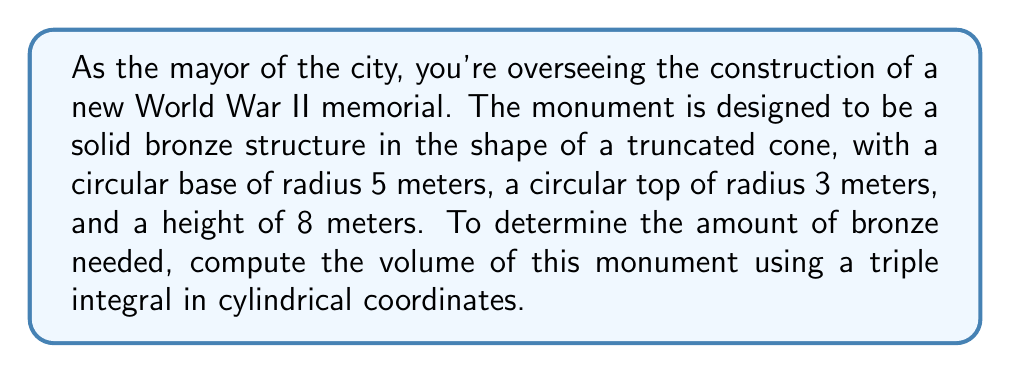Solve this math problem. To solve this problem, we'll use cylindrical coordinates $(r, \theta, z)$ and set up a triple integral to calculate the volume of the truncated cone.

1) First, let's identify the limits of integration:
   - $0 \leq \theta \leq 2\pi$ (full rotation around the z-axis)
   - $0 \leq z \leq 8$ (height of the monument)
   - For $r$, we need to find a function that describes how the radius changes with height.

2) The radius at any height $z$ can be described by the equation:
   $r(z) = 5 - \frac{1}{4}z$
   This is because the radius decreases from 5m to 3m over a height of 8m.

3) The volume element in cylindrical coordinates is $dV = r \, dr \, d\theta \, dz$.

4) We can now set up the triple integral:

   $$V = \int_0^{2\pi} \int_0^8 \int_0^{5-\frac{1}{4}z} r \, dr \, dz \, d\theta$$

5) Let's solve the innermost integral first:
   $$\int_0^{5-\frac{1}{4}z} r \, dr = \frac{1}{2}r^2 \bigg|_0^{5-\frac{1}{4}z} = \frac{1}{2}(5-\frac{1}{4}z)^2$$

6) Now our integral becomes:
   $$V = \int_0^{2\pi} \int_0^8 \frac{1}{2}(5-\frac{1}{4}z)^2 \, dz \, d\theta$$

7) Let's solve the $z$ integral:
   $$\int_0^8 \frac{1}{2}(5-\frac{1}{4}z)^2 \, dz = \frac{1}{2} \int_0^8 (25 - \frac{5}{2}z + \frac{1}{32}z^2) \, dz$$
   $$= \frac{1}{2} [25z - \frac{5}{4}z^2 + \frac{1}{96}z^3] \bigg|_0^8$$
   $$= \frac{1}{2} [200 - 80 + \frac{512}{96}] = 60 + \frac{8}{3} = \frac{188}{3}$$

8) Our final integral is:
   $$V = \int_0^{2\pi} \frac{188}{3} \, d\theta = \frac{188}{3} \cdot 2\pi = \frac{376\pi}{3}$$

Therefore, the volume of the monument is $\frac{376\pi}{3}$ cubic meters.
Answer: $\frac{376\pi}{3}$ cubic meters 